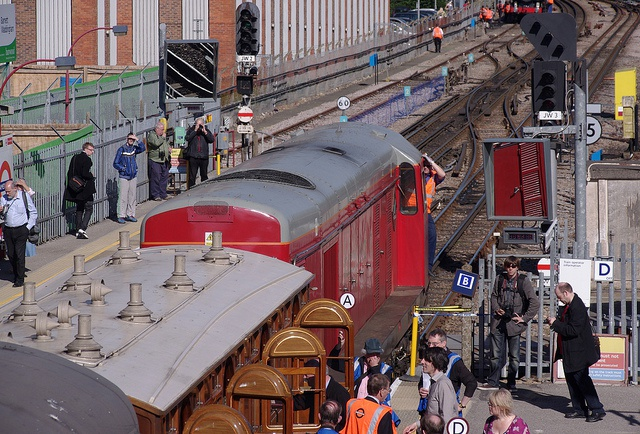Describe the objects in this image and their specific colors. I can see train in darkgray, gray, maroon, and brown tones, people in darkgray, black, maroon, gray, and brown tones, people in darkgray, black, and gray tones, people in darkgray, black, gray, and maroon tones, and people in darkgray, black, and lavender tones in this image. 